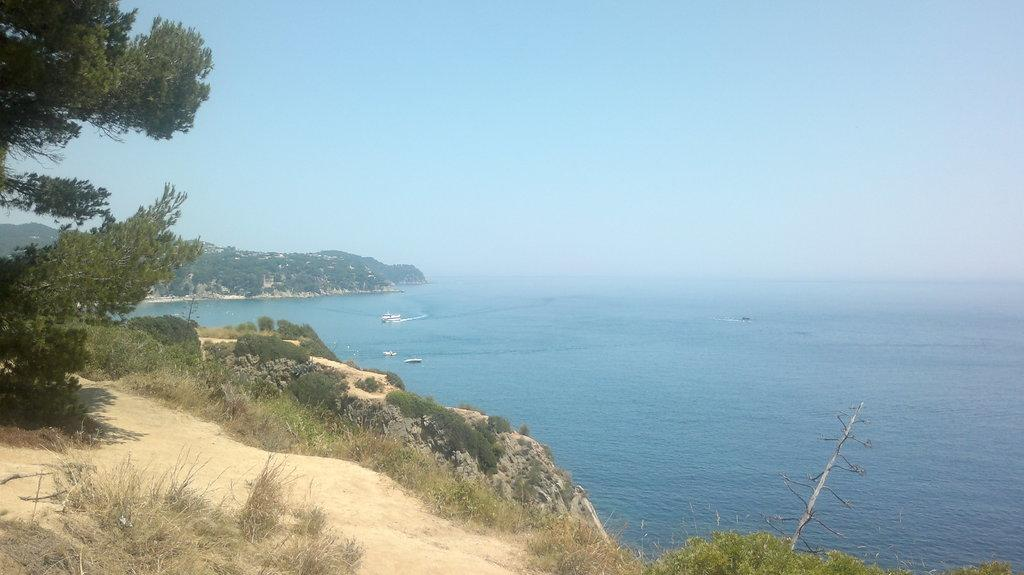What is the main subject in the center of the image? There are ships in the water in the center of the image. What can be seen in the background of the image? There are trees, mountains, and the sky visible in the background of the image. How many slaves are resting on the ships in the image? There is no mention of slaves or any people in the image; it only shows ships in the water, trees, mountains, and the sky in the background. 